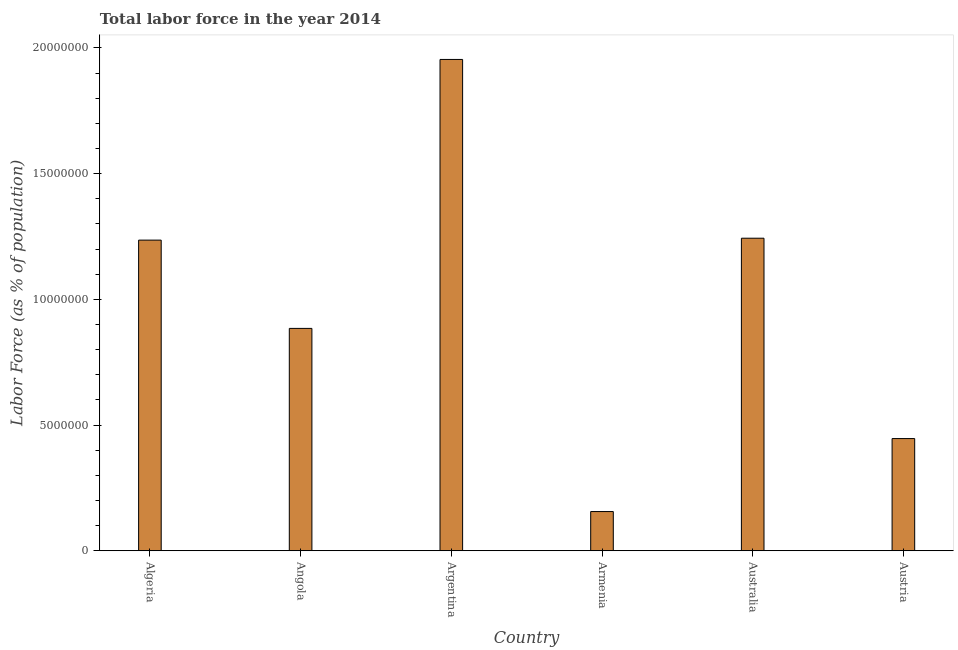Does the graph contain any zero values?
Give a very brief answer. No. Does the graph contain grids?
Make the answer very short. No. What is the title of the graph?
Offer a very short reply. Total labor force in the year 2014. What is the label or title of the Y-axis?
Give a very brief answer. Labor Force (as % of population). What is the total labor force in Angola?
Keep it short and to the point. 8.84e+06. Across all countries, what is the maximum total labor force?
Provide a succinct answer. 1.95e+07. Across all countries, what is the minimum total labor force?
Your answer should be compact. 1.56e+06. In which country was the total labor force maximum?
Ensure brevity in your answer.  Argentina. In which country was the total labor force minimum?
Make the answer very short. Armenia. What is the sum of the total labor force?
Provide a short and direct response. 5.92e+07. What is the difference between the total labor force in Armenia and Australia?
Provide a succinct answer. -1.09e+07. What is the average total labor force per country?
Your answer should be compact. 9.87e+06. What is the median total labor force?
Offer a terse response. 1.06e+07. What is the ratio of the total labor force in Algeria to that in Austria?
Your response must be concise. 2.77. What is the difference between the highest and the second highest total labor force?
Your response must be concise. 7.11e+06. Is the sum of the total labor force in Armenia and Austria greater than the maximum total labor force across all countries?
Ensure brevity in your answer.  No. What is the difference between the highest and the lowest total labor force?
Keep it short and to the point. 1.80e+07. In how many countries, is the total labor force greater than the average total labor force taken over all countries?
Provide a succinct answer. 3. What is the Labor Force (as % of population) of Algeria?
Ensure brevity in your answer.  1.24e+07. What is the Labor Force (as % of population) of Angola?
Your answer should be compact. 8.84e+06. What is the Labor Force (as % of population) in Argentina?
Provide a succinct answer. 1.95e+07. What is the Labor Force (as % of population) of Armenia?
Make the answer very short. 1.56e+06. What is the Labor Force (as % of population) in Australia?
Ensure brevity in your answer.  1.24e+07. What is the Labor Force (as % of population) of Austria?
Offer a very short reply. 4.46e+06. What is the difference between the Labor Force (as % of population) in Algeria and Angola?
Give a very brief answer. 3.51e+06. What is the difference between the Labor Force (as % of population) in Algeria and Argentina?
Your response must be concise. -7.19e+06. What is the difference between the Labor Force (as % of population) in Algeria and Armenia?
Provide a short and direct response. 1.08e+07. What is the difference between the Labor Force (as % of population) in Algeria and Australia?
Your answer should be very brief. -7.60e+04. What is the difference between the Labor Force (as % of population) in Algeria and Austria?
Make the answer very short. 7.89e+06. What is the difference between the Labor Force (as % of population) in Angola and Argentina?
Your response must be concise. -1.07e+07. What is the difference between the Labor Force (as % of population) in Angola and Armenia?
Offer a very short reply. 7.28e+06. What is the difference between the Labor Force (as % of population) in Angola and Australia?
Offer a very short reply. -3.59e+06. What is the difference between the Labor Force (as % of population) in Angola and Austria?
Offer a terse response. 4.38e+06. What is the difference between the Labor Force (as % of population) in Argentina and Armenia?
Keep it short and to the point. 1.80e+07. What is the difference between the Labor Force (as % of population) in Argentina and Australia?
Make the answer very short. 7.11e+06. What is the difference between the Labor Force (as % of population) in Argentina and Austria?
Your answer should be compact. 1.51e+07. What is the difference between the Labor Force (as % of population) in Armenia and Australia?
Your response must be concise. -1.09e+07. What is the difference between the Labor Force (as % of population) in Armenia and Austria?
Your answer should be very brief. -2.90e+06. What is the difference between the Labor Force (as % of population) in Australia and Austria?
Offer a very short reply. 7.97e+06. What is the ratio of the Labor Force (as % of population) in Algeria to that in Angola?
Your answer should be very brief. 1.4. What is the ratio of the Labor Force (as % of population) in Algeria to that in Argentina?
Provide a short and direct response. 0.63. What is the ratio of the Labor Force (as % of population) in Algeria to that in Armenia?
Ensure brevity in your answer.  7.92. What is the ratio of the Labor Force (as % of population) in Algeria to that in Australia?
Your answer should be compact. 0.99. What is the ratio of the Labor Force (as % of population) in Algeria to that in Austria?
Your answer should be very brief. 2.77. What is the ratio of the Labor Force (as % of population) in Angola to that in Argentina?
Keep it short and to the point. 0.45. What is the ratio of the Labor Force (as % of population) in Angola to that in Armenia?
Give a very brief answer. 5.67. What is the ratio of the Labor Force (as % of population) in Angola to that in Australia?
Make the answer very short. 0.71. What is the ratio of the Labor Force (as % of population) in Angola to that in Austria?
Give a very brief answer. 1.98. What is the ratio of the Labor Force (as % of population) in Argentina to that in Armenia?
Provide a short and direct response. 12.53. What is the ratio of the Labor Force (as % of population) in Argentina to that in Australia?
Your answer should be very brief. 1.57. What is the ratio of the Labor Force (as % of population) in Argentina to that in Austria?
Provide a short and direct response. 4.38. What is the ratio of the Labor Force (as % of population) in Armenia to that in Australia?
Provide a short and direct response. 0.12. What is the ratio of the Labor Force (as % of population) in Armenia to that in Austria?
Your response must be concise. 0.35. What is the ratio of the Labor Force (as % of population) in Australia to that in Austria?
Provide a succinct answer. 2.79. 